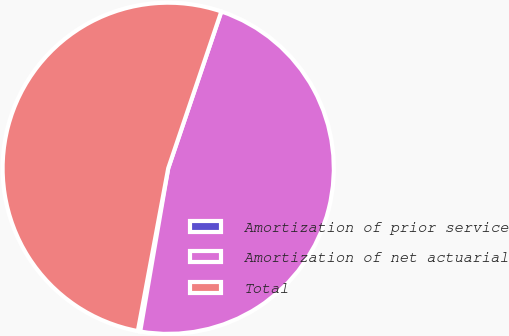Convert chart. <chart><loc_0><loc_0><loc_500><loc_500><pie_chart><fcel>Amortization of prior service<fcel>Amortization of net actuarial<fcel>Total<nl><fcel>0.23%<fcel>47.51%<fcel>52.26%<nl></chart> 